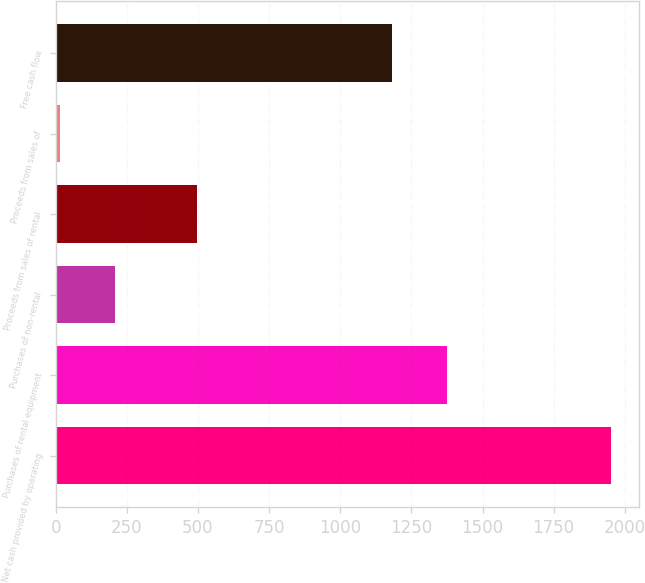Convert chart to OTSL. <chart><loc_0><loc_0><loc_500><loc_500><bar_chart><fcel>Net cash provided by operating<fcel>Purchases of rental equipment<fcel>Purchases of non-rental<fcel>Proceeds from sales of rental<fcel>Proceeds from sales of<fcel>Free cash flow<nl><fcel>1953<fcel>1375.9<fcel>207.9<fcel>496<fcel>14<fcel>1182<nl></chart> 